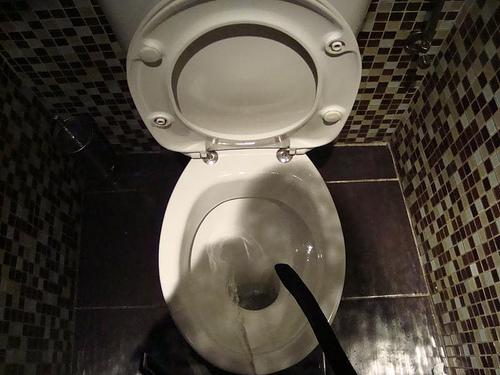Is the toilet open?
Concise answer only. Yes. Is there water?
Write a very short answer. Yes. Is this toilet in a public place?
Be succinct. Yes. 